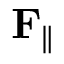Convert formula to latex. <formula><loc_0><loc_0><loc_500><loc_500>F _ { \| }</formula> 